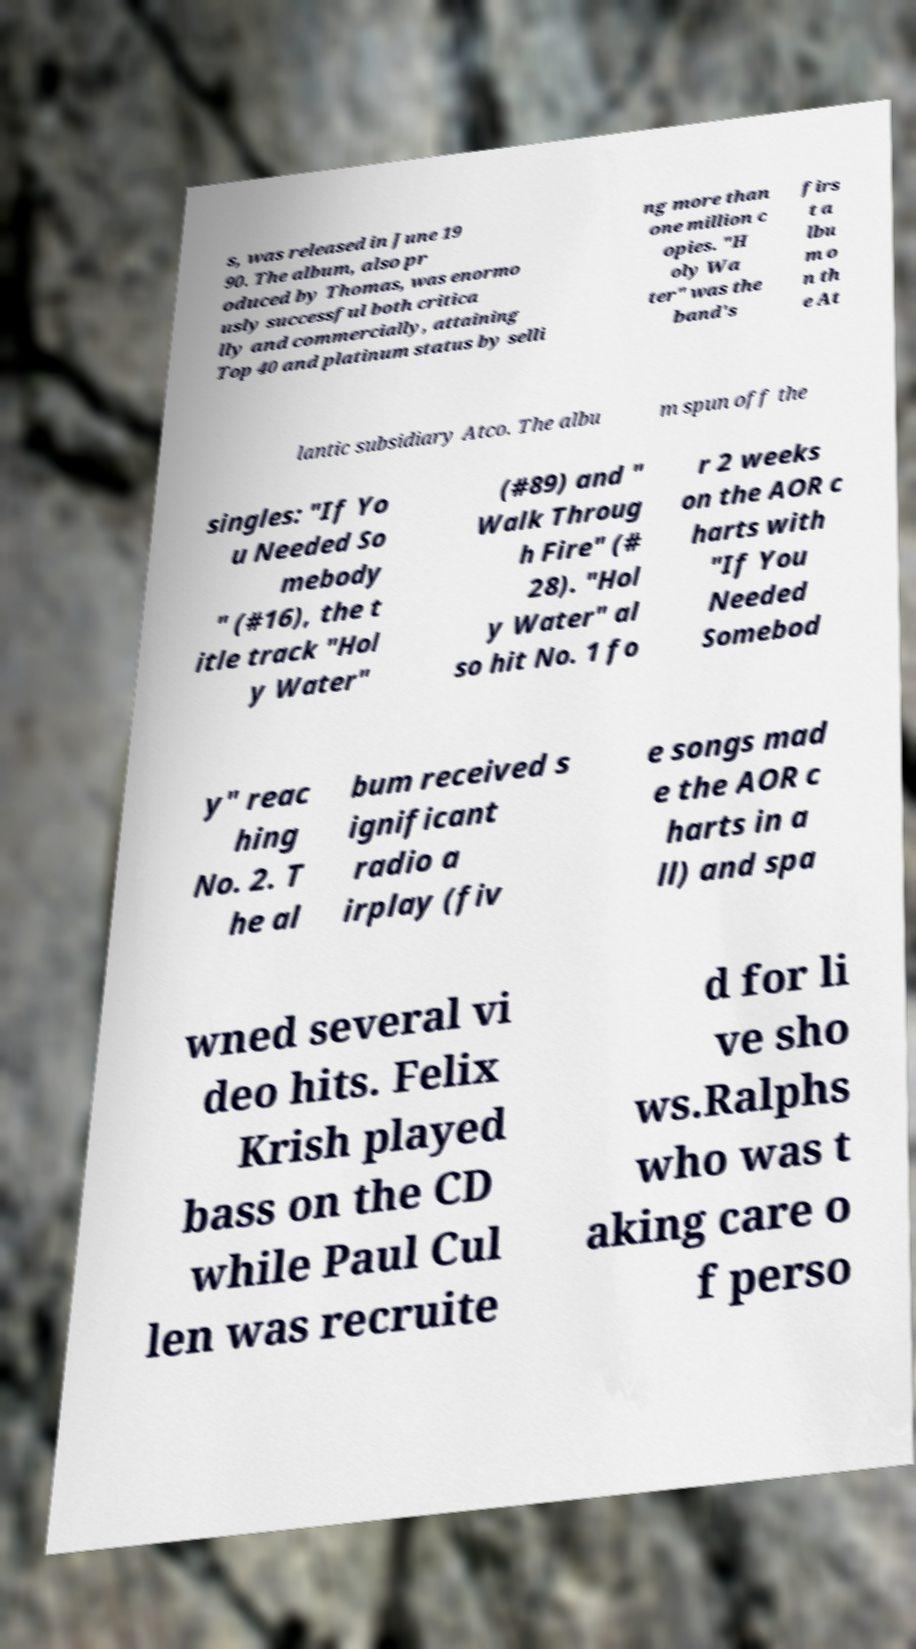Please read and relay the text visible in this image. What does it say? s, was released in June 19 90. The album, also pr oduced by Thomas, was enormo usly successful both critica lly and commercially, attaining Top 40 and platinum status by selli ng more than one million c opies. "H oly Wa ter" was the band's firs t a lbu m o n th e At lantic subsidiary Atco. The albu m spun off the singles: "If Yo u Needed So mebody " (#16), the t itle track "Hol y Water" (#89) and " Walk Throug h Fire" (# 28). "Hol y Water" al so hit No. 1 fo r 2 weeks on the AOR c harts with "If You Needed Somebod y" reac hing No. 2. T he al bum received s ignificant radio a irplay (fiv e songs mad e the AOR c harts in a ll) and spa wned several vi deo hits. Felix Krish played bass on the CD while Paul Cul len was recruite d for li ve sho ws.Ralphs who was t aking care o f perso 